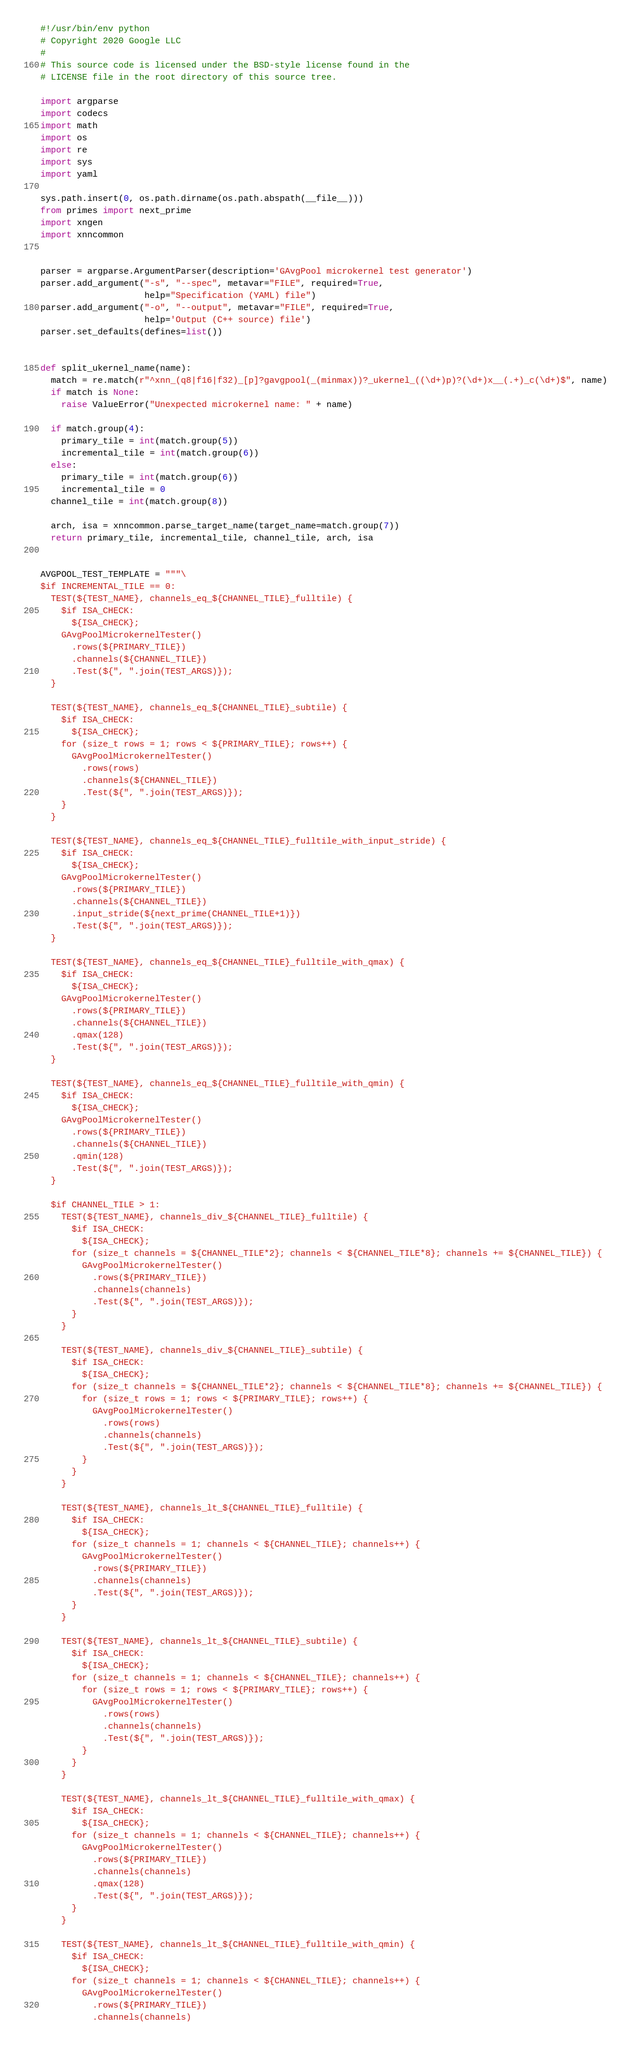Convert code to text. <code><loc_0><loc_0><loc_500><loc_500><_Python_>#!/usr/bin/env python
# Copyright 2020 Google LLC
#
# This source code is licensed under the BSD-style license found in the
# LICENSE file in the root directory of this source tree.

import argparse
import codecs
import math
import os
import re
import sys
import yaml

sys.path.insert(0, os.path.dirname(os.path.abspath(__file__)))
from primes import next_prime
import xngen
import xnncommon


parser = argparse.ArgumentParser(description='GAvgPool microkernel test generator')
parser.add_argument("-s", "--spec", metavar="FILE", required=True,
                    help="Specification (YAML) file")
parser.add_argument("-o", "--output", metavar="FILE", required=True,
                    help='Output (C++ source) file')
parser.set_defaults(defines=list())


def split_ukernel_name(name):
  match = re.match(r"^xnn_(q8|f16|f32)_[p]?gavgpool(_(minmax))?_ukernel_((\d+)p)?(\d+)x__(.+)_c(\d+)$", name)
  if match is None:
    raise ValueError("Unexpected microkernel name: " + name)

  if match.group(4):
    primary_tile = int(match.group(5))
    incremental_tile = int(match.group(6))
  else:
    primary_tile = int(match.group(6))
    incremental_tile = 0
  channel_tile = int(match.group(8))

  arch, isa = xnncommon.parse_target_name(target_name=match.group(7))
  return primary_tile, incremental_tile, channel_tile, arch, isa


AVGPOOL_TEST_TEMPLATE = """\
$if INCREMENTAL_TILE == 0:
  TEST(${TEST_NAME}, channels_eq_${CHANNEL_TILE}_fulltile) {
    $if ISA_CHECK:
      ${ISA_CHECK};
    GAvgPoolMicrokernelTester()
      .rows(${PRIMARY_TILE})
      .channels(${CHANNEL_TILE})
      .Test(${", ".join(TEST_ARGS)});
  }

  TEST(${TEST_NAME}, channels_eq_${CHANNEL_TILE}_subtile) {
    $if ISA_CHECK:
      ${ISA_CHECK};
    for (size_t rows = 1; rows < ${PRIMARY_TILE}; rows++) {
      GAvgPoolMicrokernelTester()
        .rows(rows)
        .channels(${CHANNEL_TILE})
        .Test(${", ".join(TEST_ARGS)});
    }
  }

  TEST(${TEST_NAME}, channels_eq_${CHANNEL_TILE}_fulltile_with_input_stride) {
    $if ISA_CHECK:
      ${ISA_CHECK};
    GAvgPoolMicrokernelTester()
      .rows(${PRIMARY_TILE})
      .channels(${CHANNEL_TILE})
      .input_stride(${next_prime(CHANNEL_TILE+1)})
      .Test(${", ".join(TEST_ARGS)});
  }

  TEST(${TEST_NAME}, channels_eq_${CHANNEL_TILE}_fulltile_with_qmax) {
    $if ISA_CHECK:
      ${ISA_CHECK};
    GAvgPoolMicrokernelTester()
      .rows(${PRIMARY_TILE})
      .channels(${CHANNEL_TILE})
      .qmax(128)
      .Test(${", ".join(TEST_ARGS)});
  }

  TEST(${TEST_NAME}, channels_eq_${CHANNEL_TILE}_fulltile_with_qmin) {
    $if ISA_CHECK:
      ${ISA_CHECK};
    GAvgPoolMicrokernelTester()
      .rows(${PRIMARY_TILE})
      .channels(${CHANNEL_TILE})
      .qmin(128)
      .Test(${", ".join(TEST_ARGS)});
  }

  $if CHANNEL_TILE > 1:
    TEST(${TEST_NAME}, channels_div_${CHANNEL_TILE}_fulltile) {
      $if ISA_CHECK:
        ${ISA_CHECK};
      for (size_t channels = ${CHANNEL_TILE*2}; channels < ${CHANNEL_TILE*8}; channels += ${CHANNEL_TILE}) {
        GAvgPoolMicrokernelTester()
          .rows(${PRIMARY_TILE})
          .channels(channels)
          .Test(${", ".join(TEST_ARGS)});
      }
    }

    TEST(${TEST_NAME}, channels_div_${CHANNEL_TILE}_subtile) {
      $if ISA_CHECK:
        ${ISA_CHECK};
      for (size_t channels = ${CHANNEL_TILE*2}; channels < ${CHANNEL_TILE*8}; channels += ${CHANNEL_TILE}) {
        for (size_t rows = 1; rows < ${PRIMARY_TILE}; rows++) {
          GAvgPoolMicrokernelTester()
            .rows(rows)
            .channels(channels)
            .Test(${", ".join(TEST_ARGS)});
        }
      }
    }

    TEST(${TEST_NAME}, channels_lt_${CHANNEL_TILE}_fulltile) {
      $if ISA_CHECK:
        ${ISA_CHECK};
      for (size_t channels = 1; channels < ${CHANNEL_TILE}; channels++) {
        GAvgPoolMicrokernelTester()
          .rows(${PRIMARY_TILE})
          .channels(channels)
          .Test(${", ".join(TEST_ARGS)});
      }
    }

    TEST(${TEST_NAME}, channels_lt_${CHANNEL_TILE}_subtile) {
      $if ISA_CHECK:
        ${ISA_CHECK};
      for (size_t channels = 1; channels < ${CHANNEL_TILE}; channels++) {
        for (size_t rows = 1; rows < ${PRIMARY_TILE}; rows++) {
          GAvgPoolMicrokernelTester()
            .rows(rows)
            .channels(channels)
            .Test(${", ".join(TEST_ARGS)});
        }
      }
    }

    TEST(${TEST_NAME}, channels_lt_${CHANNEL_TILE}_fulltile_with_qmax) {
      $if ISA_CHECK:
        ${ISA_CHECK};
      for (size_t channels = 1; channels < ${CHANNEL_TILE}; channels++) {
        GAvgPoolMicrokernelTester()
          .rows(${PRIMARY_TILE})
          .channels(channels)
          .qmax(128)
          .Test(${", ".join(TEST_ARGS)});
      }
    }

    TEST(${TEST_NAME}, channels_lt_${CHANNEL_TILE}_fulltile_with_qmin) {
      $if ISA_CHECK:
        ${ISA_CHECK};
      for (size_t channels = 1; channels < ${CHANNEL_TILE}; channels++) {
        GAvgPoolMicrokernelTester()
          .rows(${PRIMARY_TILE})
          .channels(channels)</code> 